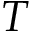<formula> <loc_0><loc_0><loc_500><loc_500>T</formula> 